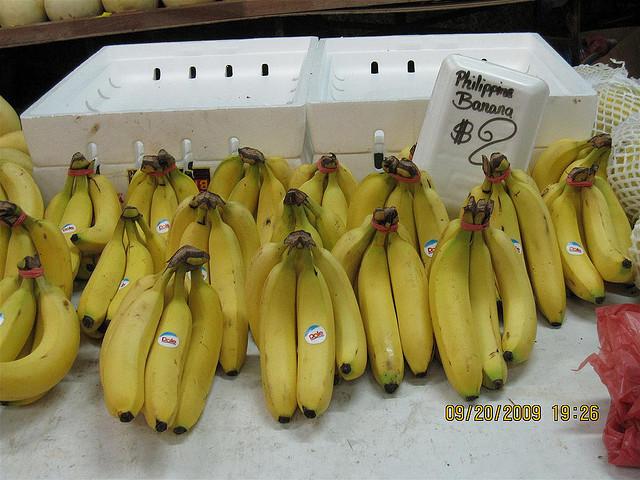How many bananas are sitting on the counter?
Give a very brief answer. 70. What kind of bananas does the sign say these are?
Quick response, please. Dole. What are the banana's lying on?
Keep it brief. Table. How much is each bunch of bananas?
Be succinct. 2 dollars. What is the fruit sitting on?
Short answer required. Table. 